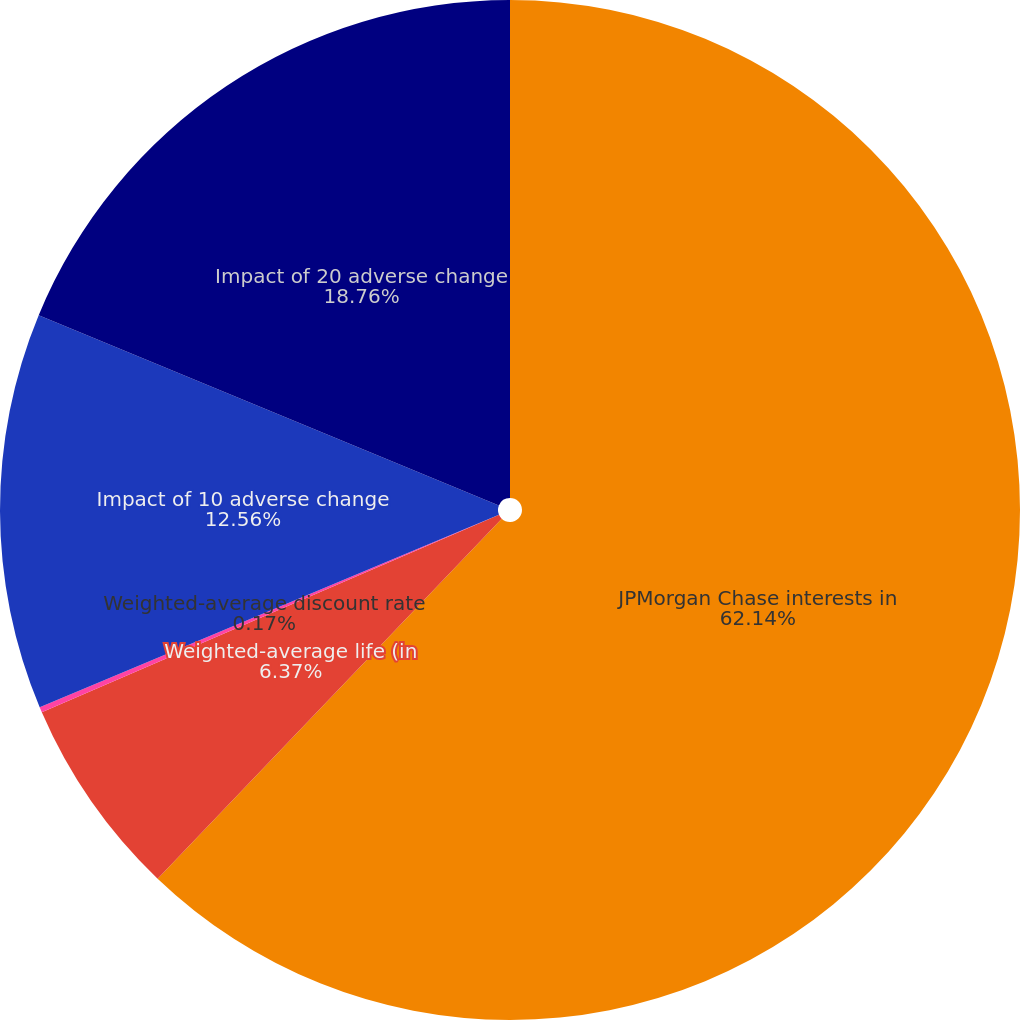<chart> <loc_0><loc_0><loc_500><loc_500><pie_chart><fcel>JPMorgan Chase interests in<fcel>Weighted-average life (in<fcel>Weighted-average discount rate<fcel>Impact of 10 adverse change<fcel>Impact of 20 adverse change<nl><fcel>62.14%<fcel>6.37%<fcel>0.17%<fcel>12.56%<fcel>18.76%<nl></chart> 